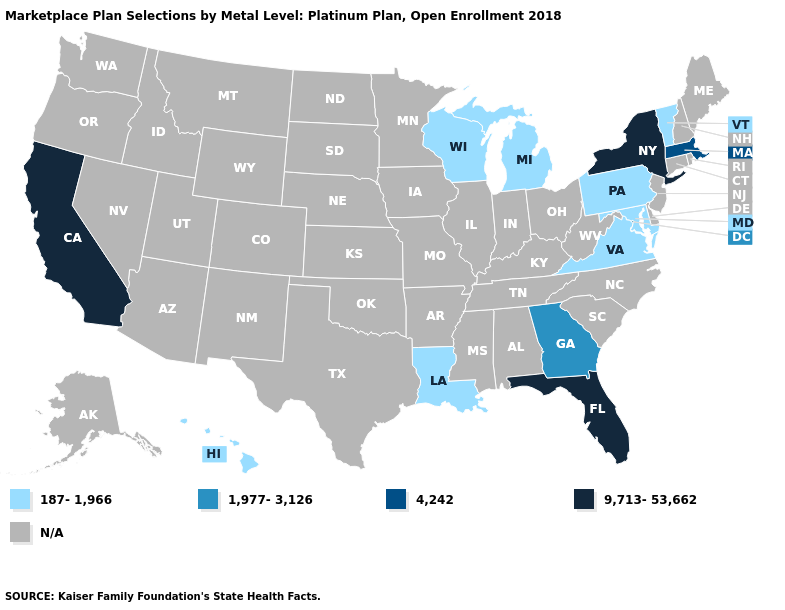What is the value of Iowa?
Concise answer only. N/A. What is the highest value in the Northeast ?
Be succinct. 9,713-53,662. What is the highest value in the MidWest ?
Keep it brief. 187-1,966. What is the lowest value in the USA?
Quick response, please. 187-1,966. Name the states that have a value in the range 9,713-53,662?
Be succinct. California, Florida, New York. What is the lowest value in states that border South Carolina?
Write a very short answer. 1,977-3,126. Name the states that have a value in the range N/A?
Keep it brief. Alabama, Alaska, Arizona, Arkansas, Colorado, Connecticut, Delaware, Idaho, Illinois, Indiana, Iowa, Kansas, Kentucky, Maine, Minnesota, Mississippi, Missouri, Montana, Nebraska, Nevada, New Hampshire, New Jersey, New Mexico, North Carolina, North Dakota, Ohio, Oklahoma, Oregon, Rhode Island, South Carolina, South Dakota, Tennessee, Texas, Utah, Washington, West Virginia, Wyoming. Name the states that have a value in the range 4,242?
Keep it brief. Massachusetts. What is the value of Louisiana?
Concise answer only. 187-1,966. Does Louisiana have the lowest value in the USA?
Concise answer only. Yes. Does the first symbol in the legend represent the smallest category?
Be succinct. Yes. What is the highest value in states that border Florida?
Be succinct. 1,977-3,126. Name the states that have a value in the range 1,977-3,126?
Keep it brief. Georgia. Name the states that have a value in the range 9,713-53,662?
Be succinct. California, Florida, New York. 